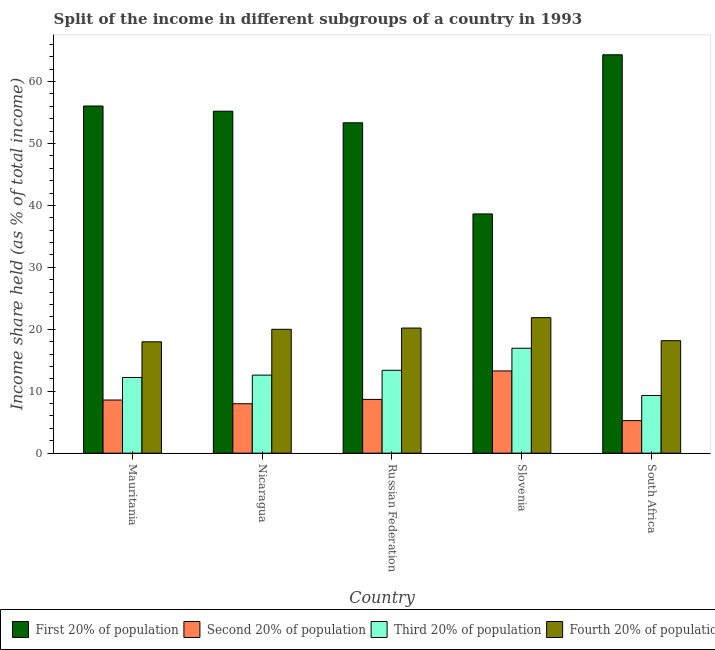How many different coloured bars are there?
Make the answer very short. 4. How many groups of bars are there?
Your answer should be very brief. 5. Are the number of bars per tick equal to the number of legend labels?
Your answer should be very brief. Yes. How many bars are there on the 1st tick from the right?
Provide a succinct answer. 4. What is the label of the 2nd group of bars from the left?
Your answer should be very brief. Nicaragua. What is the share of the income held by third 20% of the population in Slovenia?
Offer a very short reply. 16.94. Across all countries, what is the maximum share of the income held by third 20% of the population?
Make the answer very short. 16.94. Across all countries, what is the minimum share of the income held by fourth 20% of the population?
Provide a short and direct response. 17.98. In which country was the share of the income held by third 20% of the population maximum?
Provide a succinct answer. Slovenia. In which country was the share of the income held by third 20% of the population minimum?
Your response must be concise. South Africa. What is the total share of the income held by third 20% of the population in the graph?
Keep it short and to the point. 64.45. What is the difference between the share of the income held by second 20% of the population in Mauritania and that in South Africa?
Make the answer very short. 3.33. What is the difference between the share of the income held by second 20% of the population in Mauritania and the share of the income held by third 20% of the population in Nicaragua?
Ensure brevity in your answer.  -4.02. What is the average share of the income held by second 20% of the population per country?
Your response must be concise. 8.75. What is the difference between the share of the income held by third 20% of the population and share of the income held by first 20% of the population in Nicaragua?
Offer a very short reply. -42.62. What is the ratio of the share of the income held by third 20% of the population in Mauritania to that in Nicaragua?
Your response must be concise. 0.97. Is the share of the income held by fourth 20% of the population in Russian Federation less than that in Slovenia?
Your response must be concise. Yes. Is the difference between the share of the income held by third 20% of the population in Russian Federation and South Africa greater than the difference between the share of the income held by first 20% of the population in Russian Federation and South Africa?
Your answer should be compact. Yes. What is the difference between the highest and the lowest share of the income held by first 20% of the population?
Your response must be concise. 25.7. Is it the case that in every country, the sum of the share of the income held by fourth 20% of the population and share of the income held by second 20% of the population is greater than the sum of share of the income held by third 20% of the population and share of the income held by first 20% of the population?
Ensure brevity in your answer.  No. What does the 4th bar from the left in Mauritania represents?
Ensure brevity in your answer.  Fourth 20% of population. What does the 1st bar from the right in Mauritania represents?
Your answer should be very brief. Fourth 20% of population. Is it the case that in every country, the sum of the share of the income held by first 20% of the population and share of the income held by second 20% of the population is greater than the share of the income held by third 20% of the population?
Ensure brevity in your answer.  Yes. How many bars are there?
Your response must be concise. 20. Are the values on the major ticks of Y-axis written in scientific E-notation?
Your answer should be very brief. No. Does the graph contain grids?
Your response must be concise. No. What is the title of the graph?
Your answer should be very brief. Split of the income in different subgroups of a country in 1993. Does "Secondary vocational" appear as one of the legend labels in the graph?
Offer a very short reply. No. What is the label or title of the X-axis?
Provide a succinct answer. Country. What is the label or title of the Y-axis?
Provide a succinct answer. Income share held (as % of total income). What is the Income share held (as % of total income) of First 20% of population in Mauritania?
Give a very brief answer. 56.06. What is the Income share held (as % of total income) in Second 20% of population in Mauritania?
Your response must be concise. 8.58. What is the Income share held (as % of total income) in Third 20% of population in Mauritania?
Your answer should be very brief. 12.22. What is the Income share held (as % of total income) of Fourth 20% of population in Mauritania?
Your response must be concise. 17.98. What is the Income share held (as % of total income) in First 20% of population in Nicaragua?
Provide a succinct answer. 55.22. What is the Income share held (as % of total income) of Second 20% of population in Nicaragua?
Ensure brevity in your answer.  7.98. What is the Income share held (as % of total income) of Third 20% of population in Nicaragua?
Make the answer very short. 12.6. What is the Income share held (as % of total income) in First 20% of population in Russian Federation?
Keep it short and to the point. 53.35. What is the Income share held (as % of total income) of Second 20% of population in Russian Federation?
Your answer should be very brief. 8.68. What is the Income share held (as % of total income) of Third 20% of population in Russian Federation?
Provide a succinct answer. 13.38. What is the Income share held (as % of total income) in Fourth 20% of population in Russian Federation?
Offer a terse response. 20.2. What is the Income share held (as % of total income) in First 20% of population in Slovenia?
Give a very brief answer. 38.63. What is the Income share held (as % of total income) of Second 20% of population in Slovenia?
Ensure brevity in your answer.  13.28. What is the Income share held (as % of total income) of Third 20% of population in Slovenia?
Your answer should be compact. 16.94. What is the Income share held (as % of total income) of Fourth 20% of population in Slovenia?
Make the answer very short. 21.88. What is the Income share held (as % of total income) in First 20% of population in South Africa?
Make the answer very short. 64.33. What is the Income share held (as % of total income) in Second 20% of population in South Africa?
Provide a short and direct response. 5.25. What is the Income share held (as % of total income) in Third 20% of population in South Africa?
Keep it short and to the point. 9.31. What is the Income share held (as % of total income) of Fourth 20% of population in South Africa?
Your answer should be compact. 18.16. Across all countries, what is the maximum Income share held (as % of total income) of First 20% of population?
Your answer should be compact. 64.33. Across all countries, what is the maximum Income share held (as % of total income) in Second 20% of population?
Keep it short and to the point. 13.28. Across all countries, what is the maximum Income share held (as % of total income) in Third 20% of population?
Offer a very short reply. 16.94. Across all countries, what is the maximum Income share held (as % of total income) in Fourth 20% of population?
Your answer should be very brief. 21.88. Across all countries, what is the minimum Income share held (as % of total income) in First 20% of population?
Ensure brevity in your answer.  38.63. Across all countries, what is the minimum Income share held (as % of total income) in Second 20% of population?
Ensure brevity in your answer.  5.25. Across all countries, what is the minimum Income share held (as % of total income) in Third 20% of population?
Ensure brevity in your answer.  9.31. Across all countries, what is the minimum Income share held (as % of total income) in Fourth 20% of population?
Offer a terse response. 17.98. What is the total Income share held (as % of total income) of First 20% of population in the graph?
Ensure brevity in your answer.  267.59. What is the total Income share held (as % of total income) in Second 20% of population in the graph?
Keep it short and to the point. 43.77. What is the total Income share held (as % of total income) in Third 20% of population in the graph?
Your response must be concise. 64.45. What is the total Income share held (as % of total income) in Fourth 20% of population in the graph?
Offer a terse response. 98.22. What is the difference between the Income share held (as % of total income) of First 20% of population in Mauritania and that in Nicaragua?
Keep it short and to the point. 0.84. What is the difference between the Income share held (as % of total income) in Third 20% of population in Mauritania and that in Nicaragua?
Offer a very short reply. -0.38. What is the difference between the Income share held (as % of total income) of Fourth 20% of population in Mauritania and that in Nicaragua?
Keep it short and to the point. -2.02. What is the difference between the Income share held (as % of total income) of First 20% of population in Mauritania and that in Russian Federation?
Your answer should be compact. 2.71. What is the difference between the Income share held (as % of total income) in Third 20% of population in Mauritania and that in Russian Federation?
Provide a short and direct response. -1.16. What is the difference between the Income share held (as % of total income) of Fourth 20% of population in Mauritania and that in Russian Federation?
Your answer should be compact. -2.22. What is the difference between the Income share held (as % of total income) in First 20% of population in Mauritania and that in Slovenia?
Keep it short and to the point. 17.43. What is the difference between the Income share held (as % of total income) of Second 20% of population in Mauritania and that in Slovenia?
Provide a short and direct response. -4.7. What is the difference between the Income share held (as % of total income) of Third 20% of population in Mauritania and that in Slovenia?
Your answer should be very brief. -4.72. What is the difference between the Income share held (as % of total income) in First 20% of population in Mauritania and that in South Africa?
Your answer should be very brief. -8.27. What is the difference between the Income share held (as % of total income) of Second 20% of population in Mauritania and that in South Africa?
Give a very brief answer. 3.33. What is the difference between the Income share held (as % of total income) of Third 20% of population in Mauritania and that in South Africa?
Provide a succinct answer. 2.91. What is the difference between the Income share held (as % of total income) of Fourth 20% of population in Mauritania and that in South Africa?
Your answer should be very brief. -0.18. What is the difference between the Income share held (as % of total income) in First 20% of population in Nicaragua and that in Russian Federation?
Keep it short and to the point. 1.87. What is the difference between the Income share held (as % of total income) in Second 20% of population in Nicaragua and that in Russian Federation?
Provide a short and direct response. -0.7. What is the difference between the Income share held (as % of total income) in Third 20% of population in Nicaragua and that in Russian Federation?
Offer a very short reply. -0.78. What is the difference between the Income share held (as % of total income) of First 20% of population in Nicaragua and that in Slovenia?
Provide a succinct answer. 16.59. What is the difference between the Income share held (as % of total income) of Third 20% of population in Nicaragua and that in Slovenia?
Your answer should be very brief. -4.34. What is the difference between the Income share held (as % of total income) in Fourth 20% of population in Nicaragua and that in Slovenia?
Provide a succinct answer. -1.88. What is the difference between the Income share held (as % of total income) of First 20% of population in Nicaragua and that in South Africa?
Provide a short and direct response. -9.11. What is the difference between the Income share held (as % of total income) in Second 20% of population in Nicaragua and that in South Africa?
Offer a very short reply. 2.73. What is the difference between the Income share held (as % of total income) in Third 20% of population in Nicaragua and that in South Africa?
Offer a very short reply. 3.29. What is the difference between the Income share held (as % of total income) of Fourth 20% of population in Nicaragua and that in South Africa?
Provide a succinct answer. 1.84. What is the difference between the Income share held (as % of total income) in First 20% of population in Russian Federation and that in Slovenia?
Ensure brevity in your answer.  14.72. What is the difference between the Income share held (as % of total income) of Second 20% of population in Russian Federation and that in Slovenia?
Provide a succinct answer. -4.6. What is the difference between the Income share held (as % of total income) in Third 20% of population in Russian Federation and that in Slovenia?
Your answer should be compact. -3.56. What is the difference between the Income share held (as % of total income) of Fourth 20% of population in Russian Federation and that in Slovenia?
Keep it short and to the point. -1.68. What is the difference between the Income share held (as % of total income) in First 20% of population in Russian Federation and that in South Africa?
Your answer should be compact. -10.98. What is the difference between the Income share held (as % of total income) in Second 20% of population in Russian Federation and that in South Africa?
Ensure brevity in your answer.  3.43. What is the difference between the Income share held (as % of total income) of Third 20% of population in Russian Federation and that in South Africa?
Keep it short and to the point. 4.07. What is the difference between the Income share held (as % of total income) in Fourth 20% of population in Russian Federation and that in South Africa?
Provide a short and direct response. 2.04. What is the difference between the Income share held (as % of total income) of First 20% of population in Slovenia and that in South Africa?
Offer a very short reply. -25.7. What is the difference between the Income share held (as % of total income) in Second 20% of population in Slovenia and that in South Africa?
Your answer should be compact. 8.03. What is the difference between the Income share held (as % of total income) in Third 20% of population in Slovenia and that in South Africa?
Your answer should be compact. 7.63. What is the difference between the Income share held (as % of total income) in Fourth 20% of population in Slovenia and that in South Africa?
Give a very brief answer. 3.72. What is the difference between the Income share held (as % of total income) in First 20% of population in Mauritania and the Income share held (as % of total income) in Second 20% of population in Nicaragua?
Give a very brief answer. 48.08. What is the difference between the Income share held (as % of total income) in First 20% of population in Mauritania and the Income share held (as % of total income) in Third 20% of population in Nicaragua?
Your response must be concise. 43.46. What is the difference between the Income share held (as % of total income) of First 20% of population in Mauritania and the Income share held (as % of total income) of Fourth 20% of population in Nicaragua?
Make the answer very short. 36.06. What is the difference between the Income share held (as % of total income) of Second 20% of population in Mauritania and the Income share held (as % of total income) of Third 20% of population in Nicaragua?
Offer a very short reply. -4.02. What is the difference between the Income share held (as % of total income) in Second 20% of population in Mauritania and the Income share held (as % of total income) in Fourth 20% of population in Nicaragua?
Offer a terse response. -11.42. What is the difference between the Income share held (as % of total income) in Third 20% of population in Mauritania and the Income share held (as % of total income) in Fourth 20% of population in Nicaragua?
Give a very brief answer. -7.78. What is the difference between the Income share held (as % of total income) in First 20% of population in Mauritania and the Income share held (as % of total income) in Second 20% of population in Russian Federation?
Your answer should be very brief. 47.38. What is the difference between the Income share held (as % of total income) of First 20% of population in Mauritania and the Income share held (as % of total income) of Third 20% of population in Russian Federation?
Offer a terse response. 42.68. What is the difference between the Income share held (as % of total income) of First 20% of population in Mauritania and the Income share held (as % of total income) of Fourth 20% of population in Russian Federation?
Offer a terse response. 35.86. What is the difference between the Income share held (as % of total income) in Second 20% of population in Mauritania and the Income share held (as % of total income) in Fourth 20% of population in Russian Federation?
Your answer should be compact. -11.62. What is the difference between the Income share held (as % of total income) in Third 20% of population in Mauritania and the Income share held (as % of total income) in Fourth 20% of population in Russian Federation?
Offer a terse response. -7.98. What is the difference between the Income share held (as % of total income) in First 20% of population in Mauritania and the Income share held (as % of total income) in Second 20% of population in Slovenia?
Make the answer very short. 42.78. What is the difference between the Income share held (as % of total income) of First 20% of population in Mauritania and the Income share held (as % of total income) of Third 20% of population in Slovenia?
Keep it short and to the point. 39.12. What is the difference between the Income share held (as % of total income) of First 20% of population in Mauritania and the Income share held (as % of total income) of Fourth 20% of population in Slovenia?
Give a very brief answer. 34.18. What is the difference between the Income share held (as % of total income) in Second 20% of population in Mauritania and the Income share held (as % of total income) in Third 20% of population in Slovenia?
Make the answer very short. -8.36. What is the difference between the Income share held (as % of total income) in Second 20% of population in Mauritania and the Income share held (as % of total income) in Fourth 20% of population in Slovenia?
Provide a short and direct response. -13.3. What is the difference between the Income share held (as % of total income) in Third 20% of population in Mauritania and the Income share held (as % of total income) in Fourth 20% of population in Slovenia?
Ensure brevity in your answer.  -9.66. What is the difference between the Income share held (as % of total income) in First 20% of population in Mauritania and the Income share held (as % of total income) in Second 20% of population in South Africa?
Provide a short and direct response. 50.81. What is the difference between the Income share held (as % of total income) of First 20% of population in Mauritania and the Income share held (as % of total income) of Third 20% of population in South Africa?
Provide a short and direct response. 46.75. What is the difference between the Income share held (as % of total income) in First 20% of population in Mauritania and the Income share held (as % of total income) in Fourth 20% of population in South Africa?
Offer a terse response. 37.9. What is the difference between the Income share held (as % of total income) of Second 20% of population in Mauritania and the Income share held (as % of total income) of Third 20% of population in South Africa?
Your answer should be very brief. -0.73. What is the difference between the Income share held (as % of total income) in Second 20% of population in Mauritania and the Income share held (as % of total income) in Fourth 20% of population in South Africa?
Offer a very short reply. -9.58. What is the difference between the Income share held (as % of total income) in Third 20% of population in Mauritania and the Income share held (as % of total income) in Fourth 20% of population in South Africa?
Your answer should be compact. -5.94. What is the difference between the Income share held (as % of total income) in First 20% of population in Nicaragua and the Income share held (as % of total income) in Second 20% of population in Russian Federation?
Give a very brief answer. 46.54. What is the difference between the Income share held (as % of total income) of First 20% of population in Nicaragua and the Income share held (as % of total income) of Third 20% of population in Russian Federation?
Offer a terse response. 41.84. What is the difference between the Income share held (as % of total income) of First 20% of population in Nicaragua and the Income share held (as % of total income) of Fourth 20% of population in Russian Federation?
Offer a very short reply. 35.02. What is the difference between the Income share held (as % of total income) in Second 20% of population in Nicaragua and the Income share held (as % of total income) in Fourth 20% of population in Russian Federation?
Your response must be concise. -12.22. What is the difference between the Income share held (as % of total income) of Third 20% of population in Nicaragua and the Income share held (as % of total income) of Fourth 20% of population in Russian Federation?
Provide a succinct answer. -7.6. What is the difference between the Income share held (as % of total income) in First 20% of population in Nicaragua and the Income share held (as % of total income) in Second 20% of population in Slovenia?
Your response must be concise. 41.94. What is the difference between the Income share held (as % of total income) in First 20% of population in Nicaragua and the Income share held (as % of total income) in Third 20% of population in Slovenia?
Your answer should be compact. 38.28. What is the difference between the Income share held (as % of total income) in First 20% of population in Nicaragua and the Income share held (as % of total income) in Fourth 20% of population in Slovenia?
Your response must be concise. 33.34. What is the difference between the Income share held (as % of total income) in Second 20% of population in Nicaragua and the Income share held (as % of total income) in Third 20% of population in Slovenia?
Keep it short and to the point. -8.96. What is the difference between the Income share held (as % of total income) of Second 20% of population in Nicaragua and the Income share held (as % of total income) of Fourth 20% of population in Slovenia?
Offer a terse response. -13.9. What is the difference between the Income share held (as % of total income) in Third 20% of population in Nicaragua and the Income share held (as % of total income) in Fourth 20% of population in Slovenia?
Your response must be concise. -9.28. What is the difference between the Income share held (as % of total income) in First 20% of population in Nicaragua and the Income share held (as % of total income) in Second 20% of population in South Africa?
Offer a terse response. 49.97. What is the difference between the Income share held (as % of total income) in First 20% of population in Nicaragua and the Income share held (as % of total income) in Third 20% of population in South Africa?
Your answer should be very brief. 45.91. What is the difference between the Income share held (as % of total income) in First 20% of population in Nicaragua and the Income share held (as % of total income) in Fourth 20% of population in South Africa?
Keep it short and to the point. 37.06. What is the difference between the Income share held (as % of total income) in Second 20% of population in Nicaragua and the Income share held (as % of total income) in Third 20% of population in South Africa?
Keep it short and to the point. -1.33. What is the difference between the Income share held (as % of total income) of Second 20% of population in Nicaragua and the Income share held (as % of total income) of Fourth 20% of population in South Africa?
Give a very brief answer. -10.18. What is the difference between the Income share held (as % of total income) of Third 20% of population in Nicaragua and the Income share held (as % of total income) of Fourth 20% of population in South Africa?
Your response must be concise. -5.56. What is the difference between the Income share held (as % of total income) in First 20% of population in Russian Federation and the Income share held (as % of total income) in Second 20% of population in Slovenia?
Ensure brevity in your answer.  40.07. What is the difference between the Income share held (as % of total income) in First 20% of population in Russian Federation and the Income share held (as % of total income) in Third 20% of population in Slovenia?
Provide a short and direct response. 36.41. What is the difference between the Income share held (as % of total income) of First 20% of population in Russian Federation and the Income share held (as % of total income) of Fourth 20% of population in Slovenia?
Ensure brevity in your answer.  31.47. What is the difference between the Income share held (as % of total income) in Second 20% of population in Russian Federation and the Income share held (as % of total income) in Third 20% of population in Slovenia?
Give a very brief answer. -8.26. What is the difference between the Income share held (as % of total income) in Second 20% of population in Russian Federation and the Income share held (as % of total income) in Fourth 20% of population in Slovenia?
Your answer should be very brief. -13.2. What is the difference between the Income share held (as % of total income) in Third 20% of population in Russian Federation and the Income share held (as % of total income) in Fourth 20% of population in Slovenia?
Your answer should be very brief. -8.5. What is the difference between the Income share held (as % of total income) in First 20% of population in Russian Federation and the Income share held (as % of total income) in Second 20% of population in South Africa?
Offer a terse response. 48.1. What is the difference between the Income share held (as % of total income) in First 20% of population in Russian Federation and the Income share held (as % of total income) in Third 20% of population in South Africa?
Offer a very short reply. 44.04. What is the difference between the Income share held (as % of total income) in First 20% of population in Russian Federation and the Income share held (as % of total income) in Fourth 20% of population in South Africa?
Ensure brevity in your answer.  35.19. What is the difference between the Income share held (as % of total income) in Second 20% of population in Russian Federation and the Income share held (as % of total income) in Third 20% of population in South Africa?
Give a very brief answer. -0.63. What is the difference between the Income share held (as % of total income) in Second 20% of population in Russian Federation and the Income share held (as % of total income) in Fourth 20% of population in South Africa?
Ensure brevity in your answer.  -9.48. What is the difference between the Income share held (as % of total income) of Third 20% of population in Russian Federation and the Income share held (as % of total income) of Fourth 20% of population in South Africa?
Offer a very short reply. -4.78. What is the difference between the Income share held (as % of total income) in First 20% of population in Slovenia and the Income share held (as % of total income) in Second 20% of population in South Africa?
Offer a very short reply. 33.38. What is the difference between the Income share held (as % of total income) in First 20% of population in Slovenia and the Income share held (as % of total income) in Third 20% of population in South Africa?
Provide a short and direct response. 29.32. What is the difference between the Income share held (as % of total income) of First 20% of population in Slovenia and the Income share held (as % of total income) of Fourth 20% of population in South Africa?
Provide a succinct answer. 20.47. What is the difference between the Income share held (as % of total income) of Second 20% of population in Slovenia and the Income share held (as % of total income) of Third 20% of population in South Africa?
Make the answer very short. 3.97. What is the difference between the Income share held (as % of total income) of Second 20% of population in Slovenia and the Income share held (as % of total income) of Fourth 20% of population in South Africa?
Provide a short and direct response. -4.88. What is the difference between the Income share held (as % of total income) in Third 20% of population in Slovenia and the Income share held (as % of total income) in Fourth 20% of population in South Africa?
Make the answer very short. -1.22. What is the average Income share held (as % of total income) of First 20% of population per country?
Your answer should be compact. 53.52. What is the average Income share held (as % of total income) in Second 20% of population per country?
Offer a terse response. 8.75. What is the average Income share held (as % of total income) of Third 20% of population per country?
Your answer should be compact. 12.89. What is the average Income share held (as % of total income) of Fourth 20% of population per country?
Your answer should be very brief. 19.64. What is the difference between the Income share held (as % of total income) in First 20% of population and Income share held (as % of total income) in Second 20% of population in Mauritania?
Your response must be concise. 47.48. What is the difference between the Income share held (as % of total income) of First 20% of population and Income share held (as % of total income) of Third 20% of population in Mauritania?
Offer a very short reply. 43.84. What is the difference between the Income share held (as % of total income) of First 20% of population and Income share held (as % of total income) of Fourth 20% of population in Mauritania?
Give a very brief answer. 38.08. What is the difference between the Income share held (as % of total income) in Second 20% of population and Income share held (as % of total income) in Third 20% of population in Mauritania?
Your answer should be very brief. -3.64. What is the difference between the Income share held (as % of total income) in Third 20% of population and Income share held (as % of total income) in Fourth 20% of population in Mauritania?
Ensure brevity in your answer.  -5.76. What is the difference between the Income share held (as % of total income) in First 20% of population and Income share held (as % of total income) in Second 20% of population in Nicaragua?
Make the answer very short. 47.24. What is the difference between the Income share held (as % of total income) of First 20% of population and Income share held (as % of total income) of Third 20% of population in Nicaragua?
Offer a terse response. 42.62. What is the difference between the Income share held (as % of total income) in First 20% of population and Income share held (as % of total income) in Fourth 20% of population in Nicaragua?
Provide a succinct answer. 35.22. What is the difference between the Income share held (as % of total income) in Second 20% of population and Income share held (as % of total income) in Third 20% of population in Nicaragua?
Your answer should be compact. -4.62. What is the difference between the Income share held (as % of total income) in Second 20% of population and Income share held (as % of total income) in Fourth 20% of population in Nicaragua?
Ensure brevity in your answer.  -12.02. What is the difference between the Income share held (as % of total income) in First 20% of population and Income share held (as % of total income) in Second 20% of population in Russian Federation?
Provide a succinct answer. 44.67. What is the difference between the Income share held (as % of total income) of First 20% of population and Income share held (as % of total income) of Third 20% of population in Russian Federation?
Offer a terse response. 39.97. What is the difference between the Income share held (as % of total income) in First 20% of population and Income share held (as % of total income) in Fourth 20% of population in Russian Federation?
Your answer should be very brief. 33.15. What is the difference between the Income share held (as % of total income) of Second 20% of population and Income share held (as % of total income) of Third 20% of population in Russian Federation?
Make the answer very short. -4.7. What is the difference between the Income share held (as % of total income) in Second 20% of population and Income share held (as % of total income) in Fourth 20% of population in Russian Federation?
Provide a succinct answer. -11.52. What is the difference between the Income share held (as % of total income) of Third 20% of population and Income share held (as % of total income) of Fourth 20% of population in Russian Federation?
Your response must be concise. -6.82. What is the difference between the Income share held (as % of total income) of First 20% of population and Income share held (as % of total income) of Second 20% of population in Slovenia?
Ensure brevity in your answer.  25.35. What is the difference between the Income share held (as % of total income) in First 20% of population and Income share held (as % of total income) in Third 20% of population in Slovenia?
Your answer should be very brief. 21.69. What is the difference between the Income share held (as % of total income) of First 20% of population and Income share held (as % of total income) of Fourth 20% of population in Slovenia?
Keep it short and to the point. 16.75. What is the difference between the Income share held (as % of total income) of Second 20% of population and Income share held (as % of total income) of Third 20% of population in Slovenia?
Your answer should be compact. -3.66. What is the difference between the Income share held (as % of total income) of Second 20% of population and Income share held (as % of total income) of Fourth 20% of population in Slovenia?
Make the answer very short. -8.6. What is the difference between the Income share held (as % of total income) in Third 20% of population and Income share held (as % of total income) in Fourth 20% of population in Slovenia?
Your answer should be compact. -4.94. What is the difference between the Income share held (as % of total income) of First 20% of population and Income share held (as % of total income) of Second 20% of population in South Africa?
Offer a very short reply. 59.08. What is the difference between the Income share held (as % of total income) of First 20% of population and Income share held (as % of total income) of Third 20% of population in South Africa?
Give a very brief answer. 55.02. What is the difference between the Income share held (as % of total income) of First 20% of population and Income share held (as % of total income) of Fourth 20% of population in South Africa?
Your response must be concise. 46.17. What is the difference between the Income share held (as % of total income) of Second 20% of population and Income share held (as % of total income) of Third 20% of population in South Africa?
Your answer should be compact. -4.06. What is the difference between the Income share held (as % of total income) of Second 20% of population and Income share held (as % of total income) of Fourth 20% of population in South Africa?
Ensure brevity in your answer.  -12.91. What is the difference between the Income share held (as % of total income) in Third 20% of population and Income share held (as % of total income) in Fourth 20% of population in South Africa?
Provide a short and direct response. -8.85. What is the ratio of the Income share held (as % of total income) in First 20% of population in Mauritania to that in Nicaragua?
Your answer should be compact. 1.02. What is the ratio of the Income share held (as % of total income) in Second 20% of population in Mauritania to that in Nicaragua?
Provide a short and direct response. 1.08. What is the ratio of the Income share held (as % of total income) of Third 20% of population in Mauritania to that in Nicaragua?
Give a very brief answer. 0.97. What is the ratio of the Income share held (as % of total income) in Fourth 20% of population in Mauritania to that in Nicaragua?
Your answer should be very brief. 0.9. What is the ratio of the Income share held (as % of total income) in First 20% of population in Mauritania to that in Russian Federation?
Your answer should be very brief. 1.05. What is the ratio of the Income share held (as % of total income) of Second 20% of population in Mauritania to that in Russian Federation?
Your answer should be very brief. 0.99. What is the ratio of the Income share held (as % of total income) of Third 20% of population in Mauritania to that in Russian Federation?
Ensure brevity in your answer.  0.91. What is the ratio of the Income share held (as % of total income) in Fourth 20% of population in Mauritania to that in Russian Federation?
Provide a succinct answer. 0.89. What is the ratio of the Income share held (as % of total income) of First 20% of population in Mauritania to that in Slovenia?
Your answer should be very brief. 1.45. What is the ratio of the Income share held (as % of total income) of Second 20% of population in Mauritania to that in Slovenia?
Ensure brevity in your answer.  0.65. What is the ratio of the Income share held (as % of total income) of Third 20% of population in Mauritania to that in Slovenia?
Your response must be concise. 0.72. What is the ratio of the Income share held (as % of total income) of Fourth 20% of population in Mauritania to that in Slovenia?
Give a very brief answer. 0.82. What is the ratio of the Income share held (as % of total income) of First 20% of population in Mauritania to that in South Africa?
Offer a terse response. 0.87. What is the ratio of the Income share held (as % of total income) in Second 20% of population in Mauritania to that in South Africa?
Make the answer very short. 1.63. What is the ratio of the Income share held (as % of total income) of Third 20% of population in Mauritania to that in South Africa?
Make the answer very short. 1.31. What is the ratio of the Income share held (as % of total income) in Fourth 20% of population in Mauritania to that in South Africa?
Make the answer very short. 0.99. What is the ratio of the Income share held (as % of total income) in First 20% of population in Nicaragua to that in Russian Federation?
Your response must be concise. 1.04. What is the ratio of the Income share held (as % of total income) of Second 20% of population in Nicaragua to that in Russian Federation?
Make the answer very short. 0.92. What is the ratio of the Income share held (as % of total income) of Third 20% of population in Nicaragua to that in Russian Federation?
Ensure brevity in your answer.  0.94. What is the ratio of the Income share held (as % of total income) of First 20% of population in Nicaragua to that in Slovenia?
Keep it short and to the point. 1.43. What is the ratio of the Income share held (as % of total income) in Second 20% of population in Nicaragua to that in Slovenia?
Offer a terse response. 0.6. What is the ratio of the Income share held (as % of total income) in Third 20% of population in Nicaragua to that in Slovenia?
Make the answer very short. 0.74. What is the ratio of the Income share held (as % of total income) of Fourth 20% of population in Nicaragua to that in Slovenia?
Make the answer very short. 0.91. What is the ratio of the Income share held (as % of total income) in First 20% of population in Nicaragua to that in South Africa?
Make the answer very short. 0.86. What is the ratio of the Income share held (as % of total income) in Second 20% of population in Nicaragua to that in South Africa?
Ensure brevity in your answer.  1.52. What is the ratio of the Income share held (as % of total income) of Third 20% of population in Nicaragua to that in South Africa?
Keep it short and to the point. 1.35. What is the ratio of the Income share held (as % of total income) of Fourth 20% of population in Nicaragua to that in South Africa?
Give a very brief answer. 1.1. What is the ratio of the Income share held (as % of total income) in First 20% of population in Russian Federation to that in Slovenia?
Make the answer very short. 1.38. What is the ratio of the Income share held (as % of total income) of Second 20% of population in Russian Federation to that in Slovenia?
Your answer should be very brief. 0.65. What is the ratio of the Income share held (as % of total income) in Third 20% of population in Russian Federation to that in Slovenia?
Provide a succinct answer. 0.79. What is the ratio of the Income share held (as % of total income) of Fourth 20% of population in Russian Federation to that in Slovenia?
Provide a short and direct response. 0.92. What is the ratio of the Income share held (as % of total income) of First 20% of population in Russian Federation to that in South Africa?
Provide a short and direct response. 0.83. What is the ratio of the Income share held (as % of total income) of Second 20% of population in Russian Federation to that in South Africa?
Offer a very short reply. 1.65. What is the ratio of the Income share held (as % of total income) in Third 20% of population in Russian Federation to that in South Africa?
Give a very brief answer. 1.44. What is the ratio of the Income share held (as % of total income) of Fourth 20% of population in Russian Federation to that in South Africa?
Provide a succinct answer. 1.11. What is the ratio of the Income share held (as % of total income) of First 20% of population in Slovenia to that in South Africa?
Keep it short and to the point. 0.6. What is the ratio of the Income share held (as % of total income) of Second 20% of population in Slovenia to that in South Africa?
Your response must be concise. 2.53. What is the ratio of the Income share held (as % of total income) of Third 20% of population in Slovenia to that in South Africa?
Your answer should be compact. 1.82. What is the ratio of the Income share held (as % of total income) in Fourth 20% of population in Slovenia to that in South Africa?
Give a very brief answer. 1.2. What is the difference between the highest and the second highest Income share held (as % of total income) in First 20% of population?
Your response must be concise. 8.27. What is the difference between the highest and the second highest Income share held (as % of total income) in Second 20% of population?
Ensure brevity in your answer.  4.6. What is the difference between the highest and the second highest Income share held (as % of total income) in Third 20% of population?
Your answer should be compact. 3.56. What is the difference between the highest and the second highest Income share held (as % of total income) of Fourth 20% of population?
Offer a terse response. 1.68. What is the difference between the highest and the lowest Income share held (as % of total income) of First 20% of population?
Your response must be concise. 25.7. What is the difference between the highest and the lowest Income share held (as % of total income) of Second 20% of population?
Your answer should be compact. 8.03. What is the difference between the highest and the lowest Income share held (as % of total income) in Third 20% of population?
Make the answer very short. 7.63. What is the difference between the highest and the lowest Income share held (as % of total income) in Fourth 20% of population?
Your answer should be very brief. 3.9. 